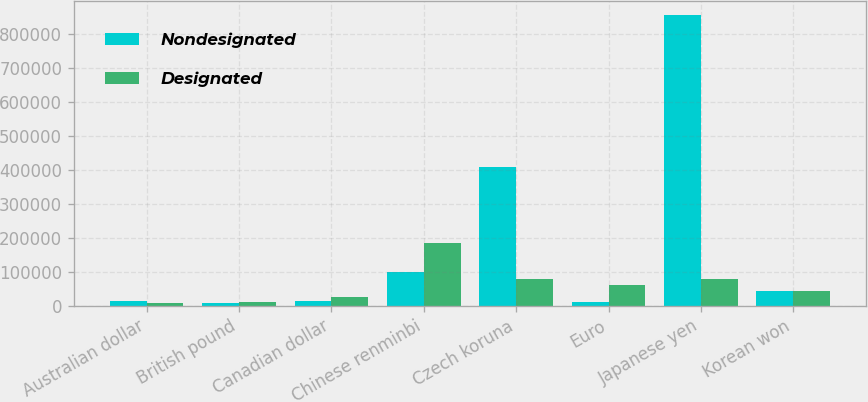Convert chart to OTSL. <chart><loc_0><loc_0><loc_500><loc_500><stacked_bar_chart><ecel><fcel>Australian dollar<fcel>British pound<fcel>Canadian dollar<fcel>Chinese renminbi<fcel>Czech koruna<fcel>Euro<fcel>Japanese yen<fcel>Korean won<nl><fcel>Nondesignated<fcel>14160<fcel>7230<fcel>12410<fcel>98780<fcel>409710<fcel>9441<fcel>856750<fcel>43493<nl><fcel>Designated<fcel>7313<fcel>11639<fcel>25992<fcel>183851<fcel>79761<fcel>60994<fcel>78828<fcel>43493<nl></chart> 